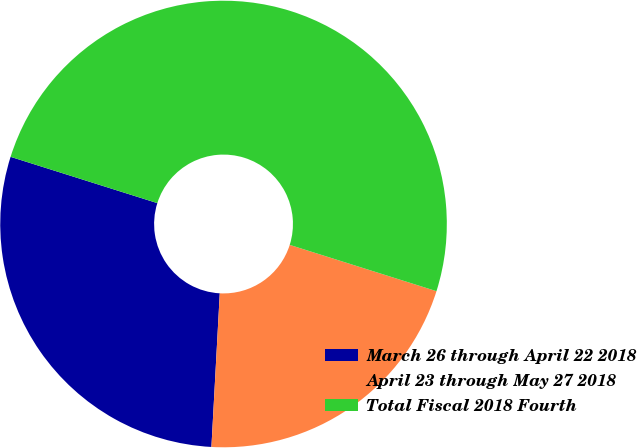Convert chart to OTSL. <chart><loc_0><loc_0><loc_500><loc_500><pie_chart><fcel>March 26 through April 22 2018<fcel>April 23 through May 27 2018<fcel>Total Fiscal 2018 Fourth<nl><fcel>29.0%<fcel>21.0%<fcel>50.0%<nl></chart> 